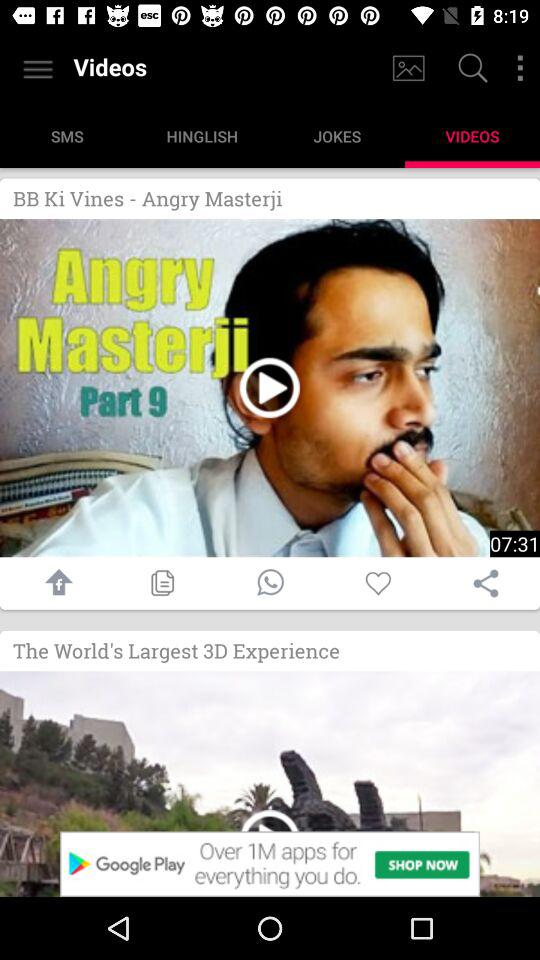What is the length of the video? The length of the video is 7 minutes and 31 seconds. 